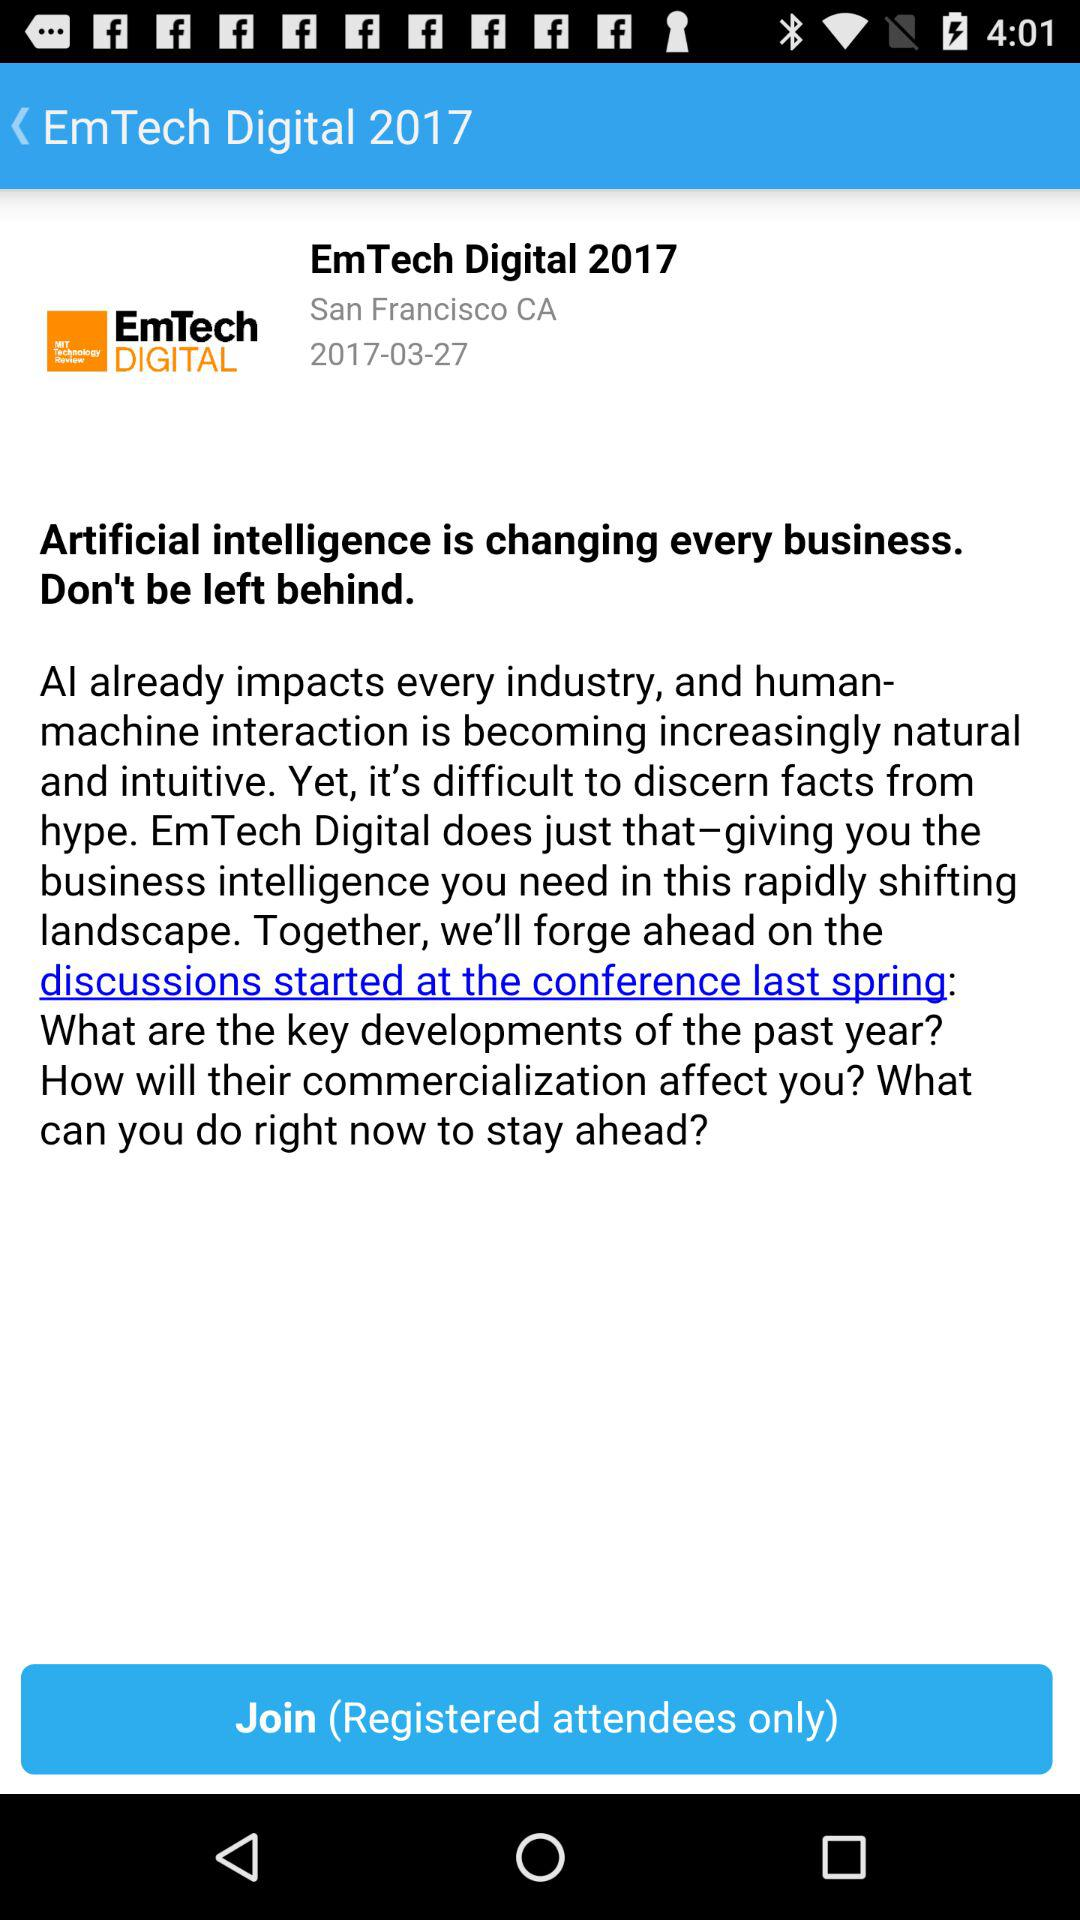What is the date of the "EmTech Digital 2017"? The date is March 27, 2017. 